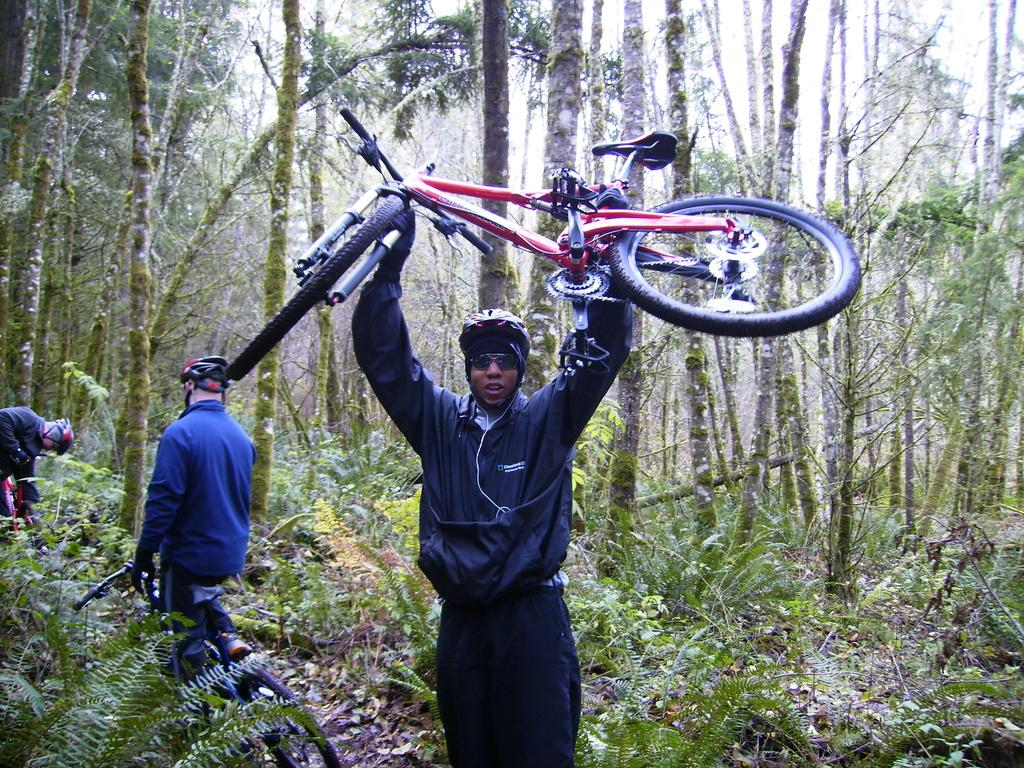Who is present in the image? There is a man in the image. What is the man wearing? The man is wearing a jacket. What is the man doing in the image? The man is lifting a cycle. Where does the scene take place? The scene takes place on a grassland. What can be seen in the background of the image? There are trees in the background. Are there any other people in the image besides the man lifting the cycle? Yes, there are two men standing on the cycle on the left side of the image. How many babies are sitting on the cycle in the image? There are no babies present in the image; it features two men standing on the cycle. What type of screw is being used to hold the cycle together in the image? There is no screw visible in the image; it is focused on the people and their actions. 